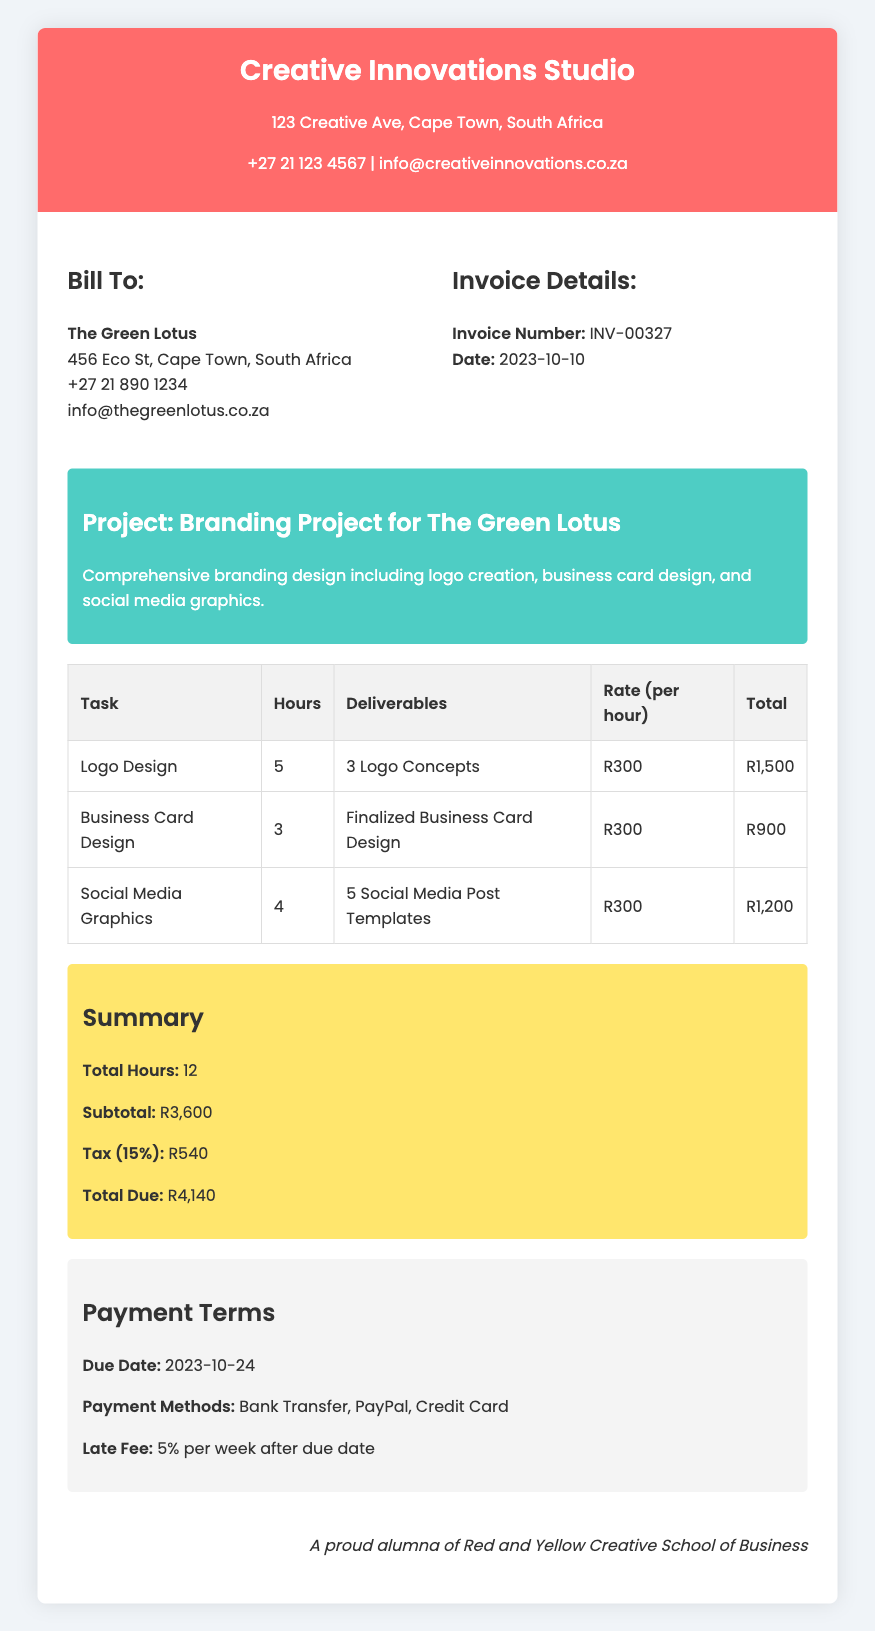What is the invoice number? The invoice number is listed under Invoice Details, which is INV-00327.
Answer: INV-00327 What is the total due amount? The total due amount is found in the Summary section, which states R4,140.
Answer: R4,140 How many hours were worked in total? The total hours worked is summarized in the Summary section, which shows 12 hours.
Answer: 12 What is the due date for payment? The due date for payment is mentioned in the Payment Terms section, which indicates 2023-10-24.
Answer: 2023-10-24 Which task took the most hours? The task with the most hours can be determined by comparing the hours listed, with Logo Design taking 5 hours.
Answer: Logo Design What is the tax percentage applied? The tax percentage is mentioned in the Summary section as 15%.
Answer: 15% What payment methods are accepted? Accepted payment methods are listed in the Payment Terms section, including Bank Transfer, PayPal, and Credit Card.
Answer: Bank Transfer, PayPal, Credit Card How many social media post templates were provided? The number of social media post templates is detailed in the deliverables section of the Social Media Graphics task, which states 5 templates.
Answer: 5 Social Media Post Templates Who is the bill addressed to? The bill is addressed to The Green Lotus, which is specified in the Bill To section.
Answer: The Green Lotus 